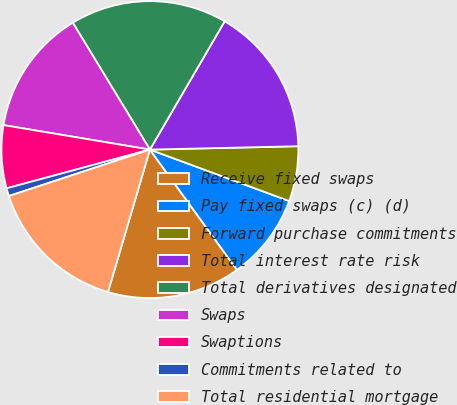<chart> <loc_0><loc_0><loc_500><loc_500><pie_chart><fcel>Receive fixed swaps<fcel>Pay fixed swaps (c) (d)<fcel>Forward purchase commitments<fcel>Total interest rate risk<fcel>Total derivatives designated<fcel>Swaps<fcel>Swaptions<fcel>Commitments related to<fcel>Total residential mortgage<nl><fcel>14.53%<fcel>9.4%<fcel>5.99%<fcel>16.24%<fcel>17.09%<fcel>13.67%<fcel>6.84%<fcel>0.86%<fcel>15.38%<nl></chart> 